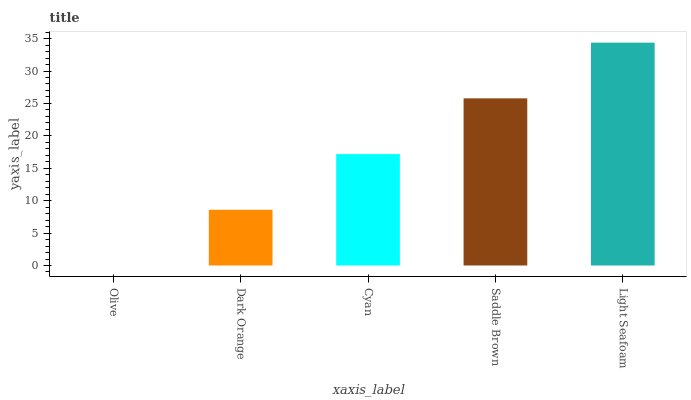Is Olive the minimum?
Answer yes or no. Yes. Is Light Seafoam the maximum?
Answer yes or no. Yes. Is Dark Orange the minimum?
Answer yes or no. No. Is Dark Orange the maximum?
Answer yes or no. No. Is Dark Orange greater than Olive?
Answer yes or no. Yes. Is Olive less than Dark Orange?
Answer yes or no. Yes. Is Olive greater than Dark Orange?
Answer yes or no. No. Is Dark Orange less than Olive?
Answer yes or no. No. Is Cyan the high median?
Answer yes or no. Yes. Is Cyan the low median?
Answer yes or no. Yes. Is Olive the high median?
Answer yes or no. No. Is Olive the low median?
Answer yes or no. No. 